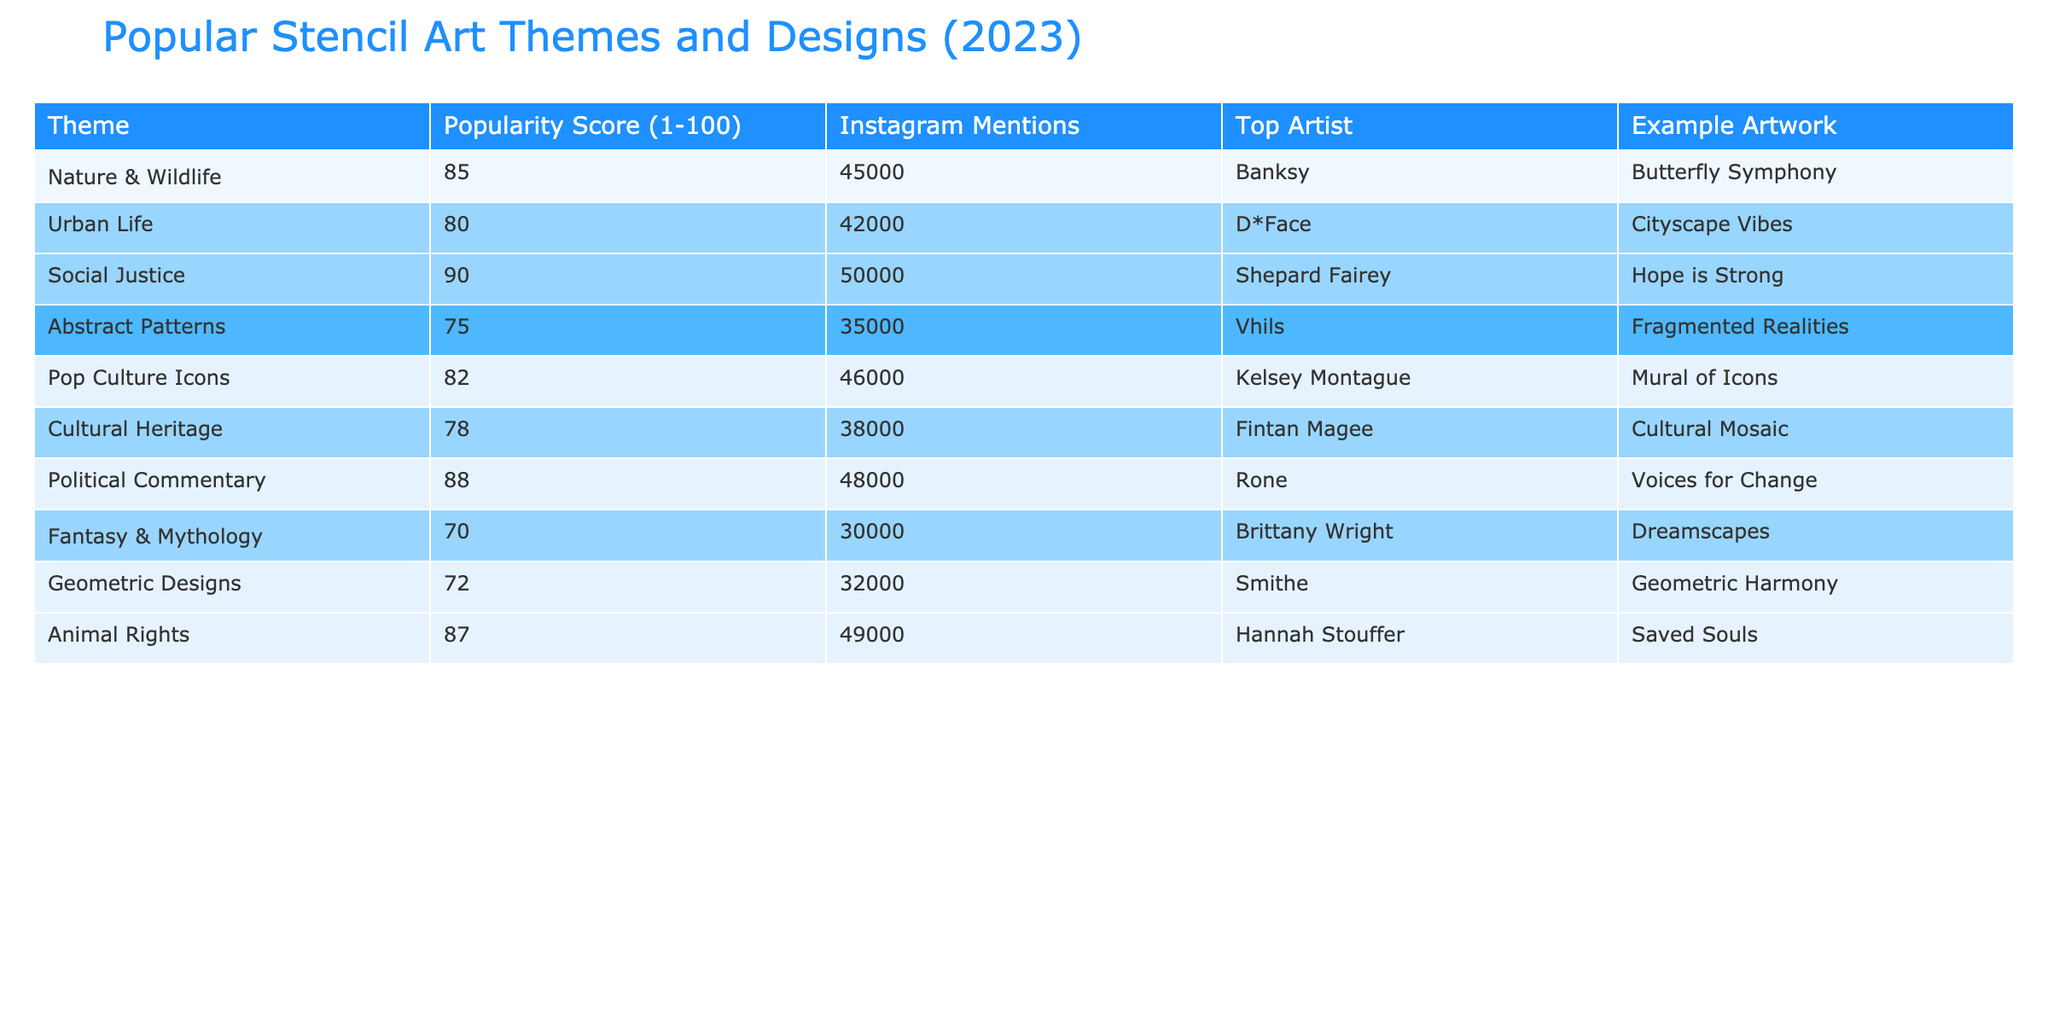What theme has the highest popularity score? The table shows that the 'Social Justice' theme has the highest popularity score at 90.
Answer: Social Justice Who is the top artist associated with the 'Animal Rights' theme? According to the table, the top artist for the 'Animal Rights' theme is Hannah Stouffer.
Answer: Hannah Stouffer How many Instagram mentions does the 'Urban Life' theme have? The table indicates that the 'Urban Life' theme has 42,000 Instagram mentions.
Answer: 42,000 What is the average popularity score of all themes? The sum of all popularity scores (85 + 80 + 90 + 75 + 82 + 78 + 88 + 70 + 72 + 87) is  826. There are 10 themes, so the average is 826 / 10 = 82.6.
Answer: 82.6 Is 'Cultural Heritage' theme more popular than 'Geometric Designs'? The popularity score for 'Cultural Heritage' is 78, while 'Geometric Designs' has a score of 72. Since 78 is greater than 72, the statement is true.
Answer: Yes Which theme has fewer than 35000 Instagram mentions? The table shows that the 'Fantasy & Mythology' theme has 30,000 mentions, which is fewer than 35,000.
Answer: Fantasy & Mythology If we compare 'Nature & Wildlife' and 'Pop Culture Icons', how much more popular is 'Nature & Wildlife'? 'Nature & Wildlife' has a popularity score of 85 and 'Pop Culture Icons' has a score of 82. The difference in popularity is 85 - 82 = 3.
Answer: 3 Which theme has the most Instagram mentions and what is its score? The 'Social Justice' theme has the most Instagram mentions at 50,000, with a popularity score of 90.
Answer: Social Justice, 90 Are there more themes focused on societal issues than on abstract designs? The themes focused on societal issues are 'Social Justice', 'Animal Rights', and 'Political Commentary', totaling 3. The abstract designs are 'Abstract Patterns' and 'Geometric Designs', totaling 2. Since 3 > 2, the answer is yes.
Answer: Yes Which artist created the 'Hope is Strong' artwork? The table indicates that the artwork 'Hope is Strong' was created by Shepard Fairey, who is associated with the 'Social Justice' theme.
Answer: Shepard Fairey 